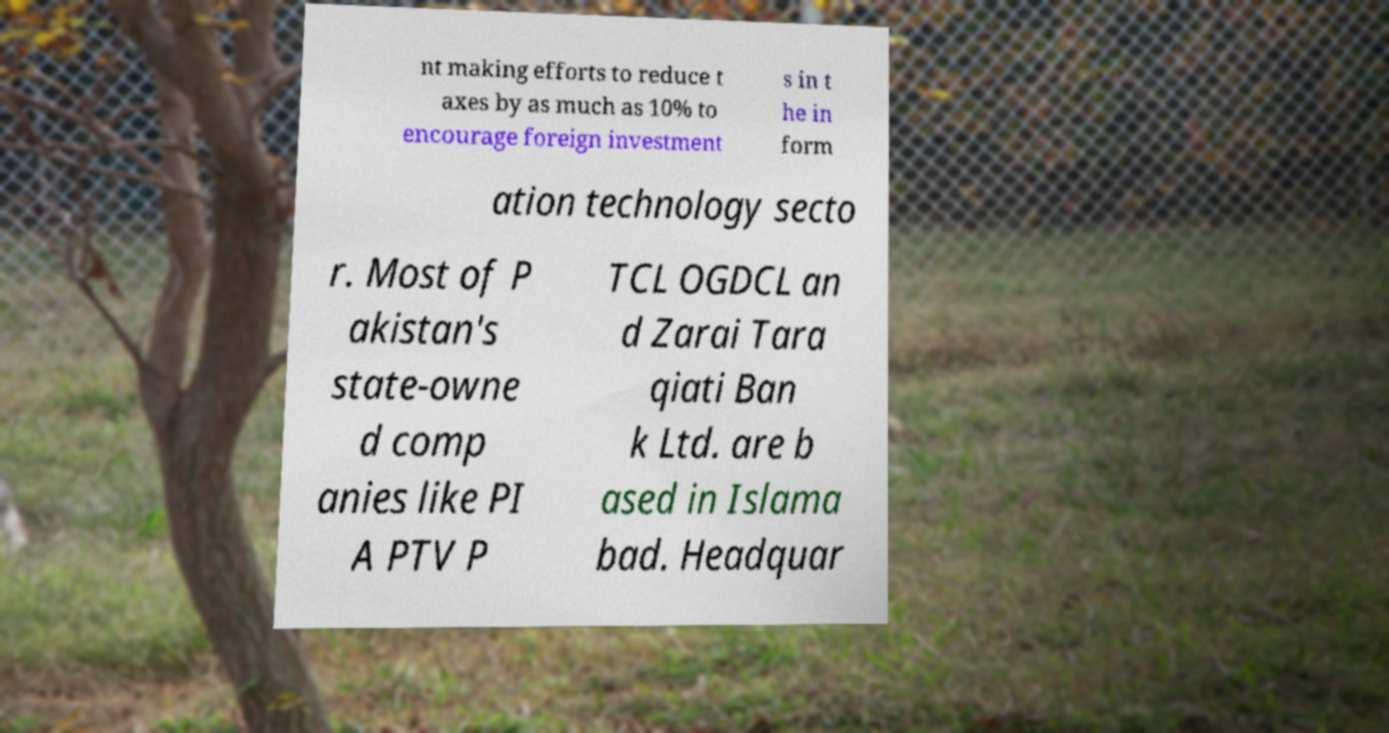I need the written content from this picture converted into text. Can you do that? nt making efforts to reduce t axes by as much as 10% to encourage foreign investment s in t he in form ation technology secto r. Most of P akistan's state-owne d comp anies like PI A PTV P TCL OGDCL an d Zarai Tara qiati Ban k Ltd. are b ased in Islama bad. Headquar 